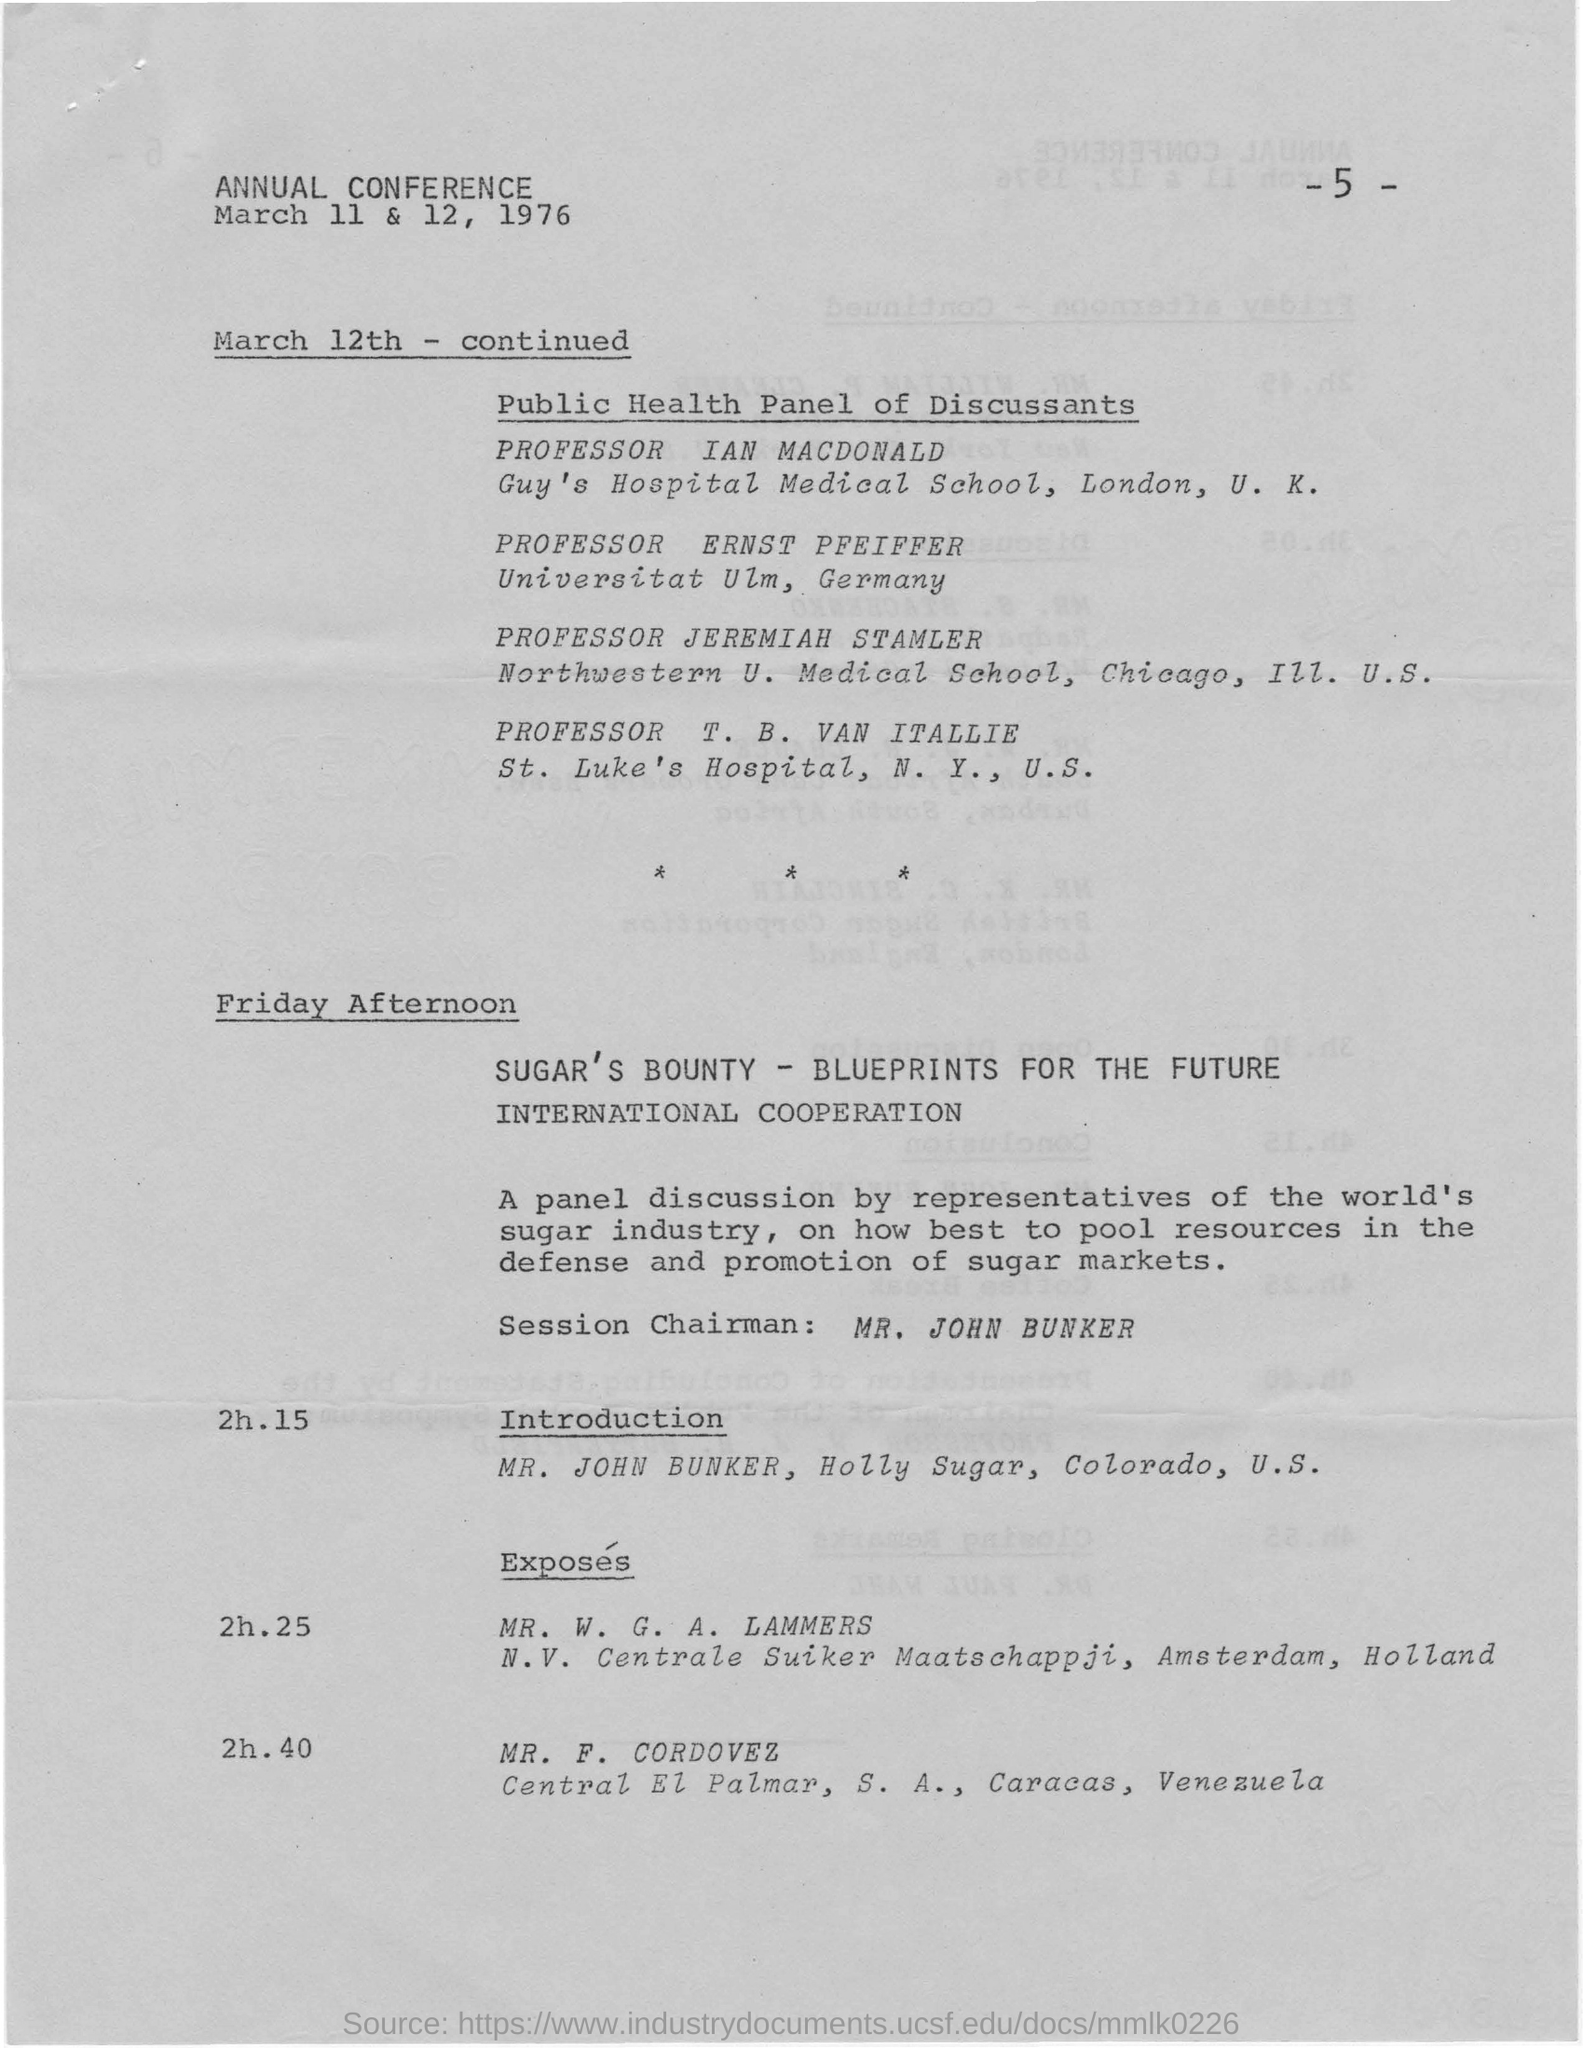In which year this conference is held?
Make the answer very short. 1976. Who is the session chairman for friday afternoon ?
Provide a succinct answer. Mr. john bunker. What is the agenda at the time of 2h.15 on friday afternoon ?
Keep it short and to the point. INTRODUCTION. Who is the session chairman for the panel discussion?
Make the answer very short. MR. JOHN BUNKER. At what time does exposes start?
Provide a short and direct response. 2h.25. 